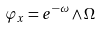Convert formula to latex. <formula><loc_0><loc_0><loc_500><loc_500>\varphi _ { x } = e ^ { - \omega } \wedge \Omega</formula> 